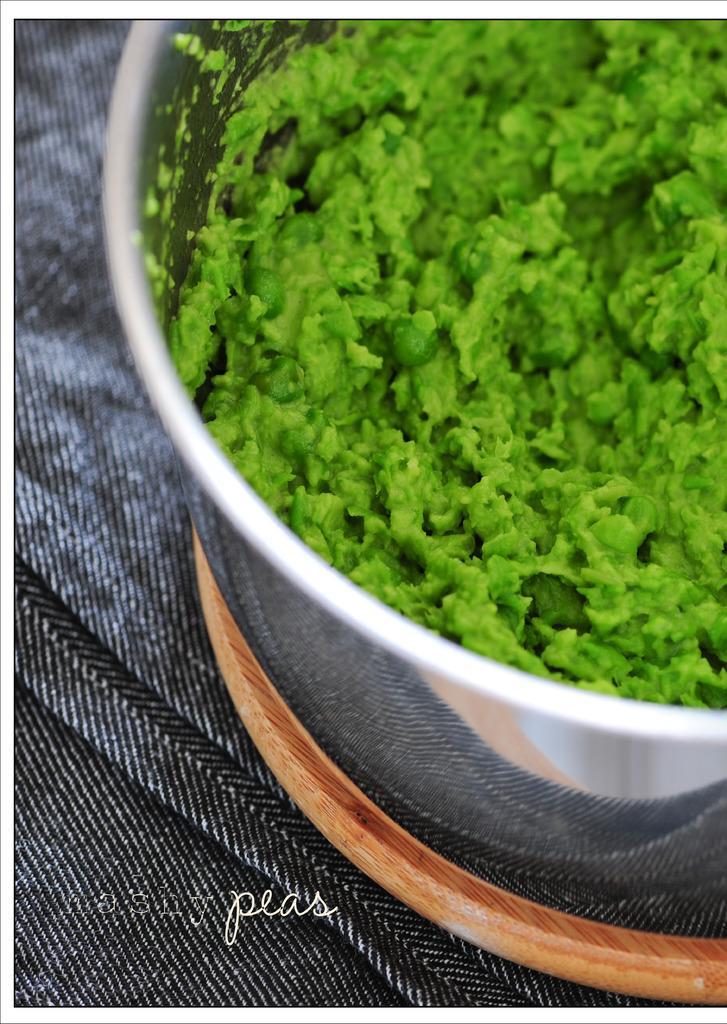Could you give a brief overview of what you see in this image? In this image we can see a food item in a bowl. At the bottom of the image, we can see a cloth, wooden object and a watermark. 